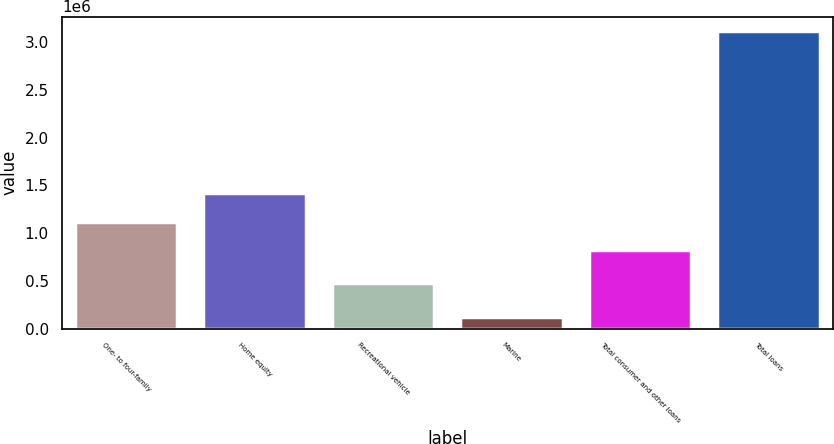Convert chart. <chart><loc_0><loc_0><loc_500><loc_500><bar_chart><fcel>One- to four-family<fcel>Home equity<fcel>Recreational vehicle<fcel>Marine<fcel>Total consumer and other loans<fcel>Total loans<nl><fcel>1.1186e+06<fcel>1.41717e+06<fcel>482923<fcel>124695<fcel>820024<fcel>3.11041e+06<nl></chart> 